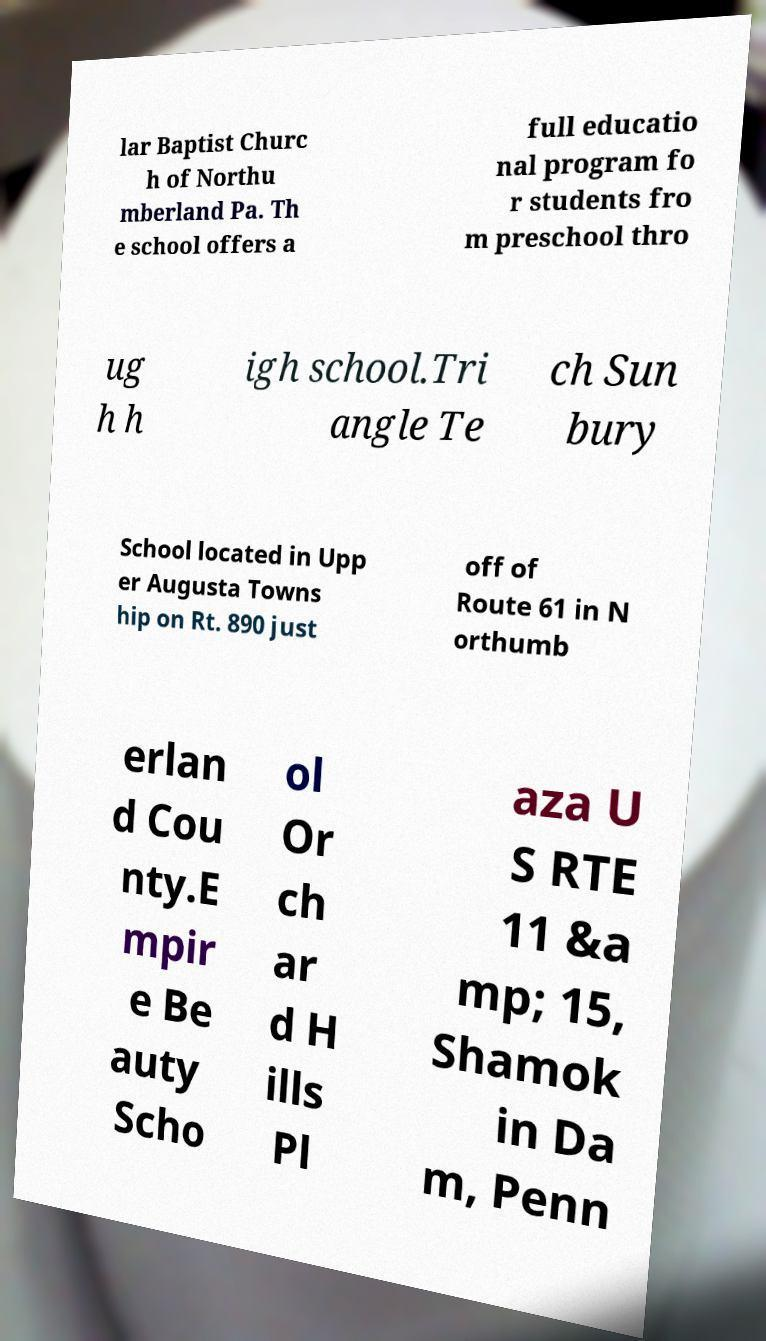I need the written content from this picture converted into text. Can you do that? lar Baptist Churc h of Northu mberland Pa. Th e school offers a full educatio nal program fo r students fro m preschool thro ug h h igh school.Tri angle Te ch Sun bury School located in Upp er Augusta Towns hip on Rt. 890 just off of Route 61 in N orthumb erlan d Cou nty.E mpir e Be auty Scho ol Or ch ar d H ills Pl aza U S RTE 11 &a mp; 15, Shamok in Da m, Penn 